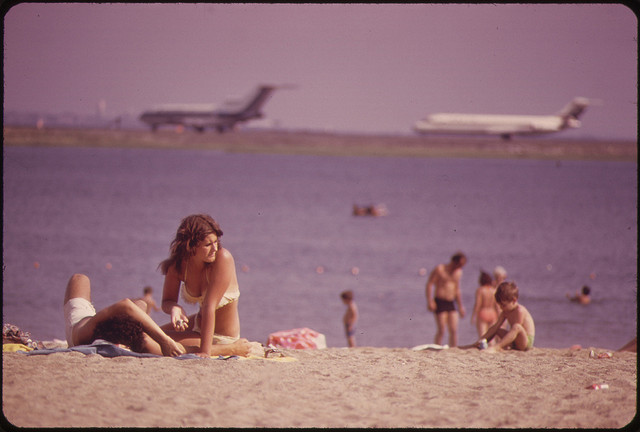How many rolls of toilet paper are on the toilet? There appear to be no rolls of toilet paper visible in the image. Instead, the picture shows a beach scene with individuals sunbathing and swimming, with airplanes in the background, indicating proximity to an airport. 